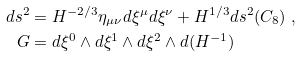Convert formula to latex. <formula><loc_0><loc_0><loc_500><loc_500>d s ^ { 2 } & = H ^ { - 2 / 3 } \eta _ { \mu \nu } d \xi ^ { \mu } d \xi ^ { \nu } + H ^ { 1 / 3 } d s ^ { 2 } ( C _ { 8 } ) \ , \\ G & = d \xi ^ { 0 } \wedge d \xi ^ { 1 } \wedge d \xi ^ { 2 } \wedge d ( H ^ { - 1 } )</formula> 